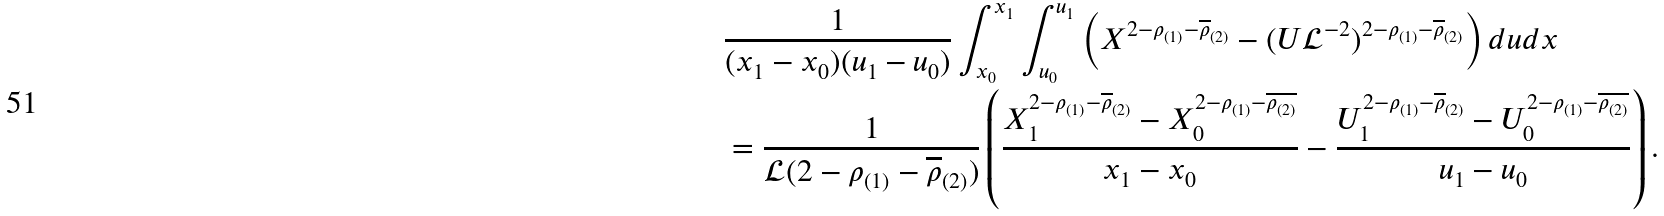Convert formula to latex. <formula><loc_0><loc_0><loc_500><loc_500>& \frac { 1 } { ( x _ { 1 } - x _ { 0 } ) ( u _ { 1 } - u _ { 0 } ) } \int _ { x _ { 0 } } ^ { x _ { 1 } } \int _ { u _ { 0 } } ^ { u _ { 1 } } \left ( X ^ { 2 - \rho _ { ( 1 ) } - \overline { \rho } _ { ( 2 ) } } - ( U \mathcal { L } ^ { - 2 } ) ^ { 2 - \rho _ { ( 1 ) } - \overline { \rho } _ { ( 2 ) } } \right ) d u d x \\ & = \frac { 1 } { \mathcal { L } ( 2 - \rho _ { ( 1 ) } - \overline { \rho } _ { ( 2 ) } ) } \left ( \frac { X _ { 1 } ^ { 2 - \rho _ { ( 1 ) } - \overline { \rho } _ { ( 2 ) } } - X _ { 0 } ^ { 2 - \rho _ { ( 1 ) } - \overline { \rho _ { ( 2 ) } } } } { x _ { 1 } - x _ { 0 } } - \frac { U _ { 1 } ^ { 2 - \rho _ { ( 1 ) } - \overline { \rho } _ { ( 2 ) } } - U _ { 0 } ^ { 2 - \rho _ { ( 1 ) } - \overline { \rho _ { ( 2 ) } } } } { u _ { 1 } - u _ { 0 } } \right ) .</formula> 